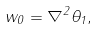Convert formula to latex. <formula><loc_0><loc_0><loc_500><loc_500>w _ { 0 } = \nabla ^ { 2 } \theta _ { 1 } ,</formula> 